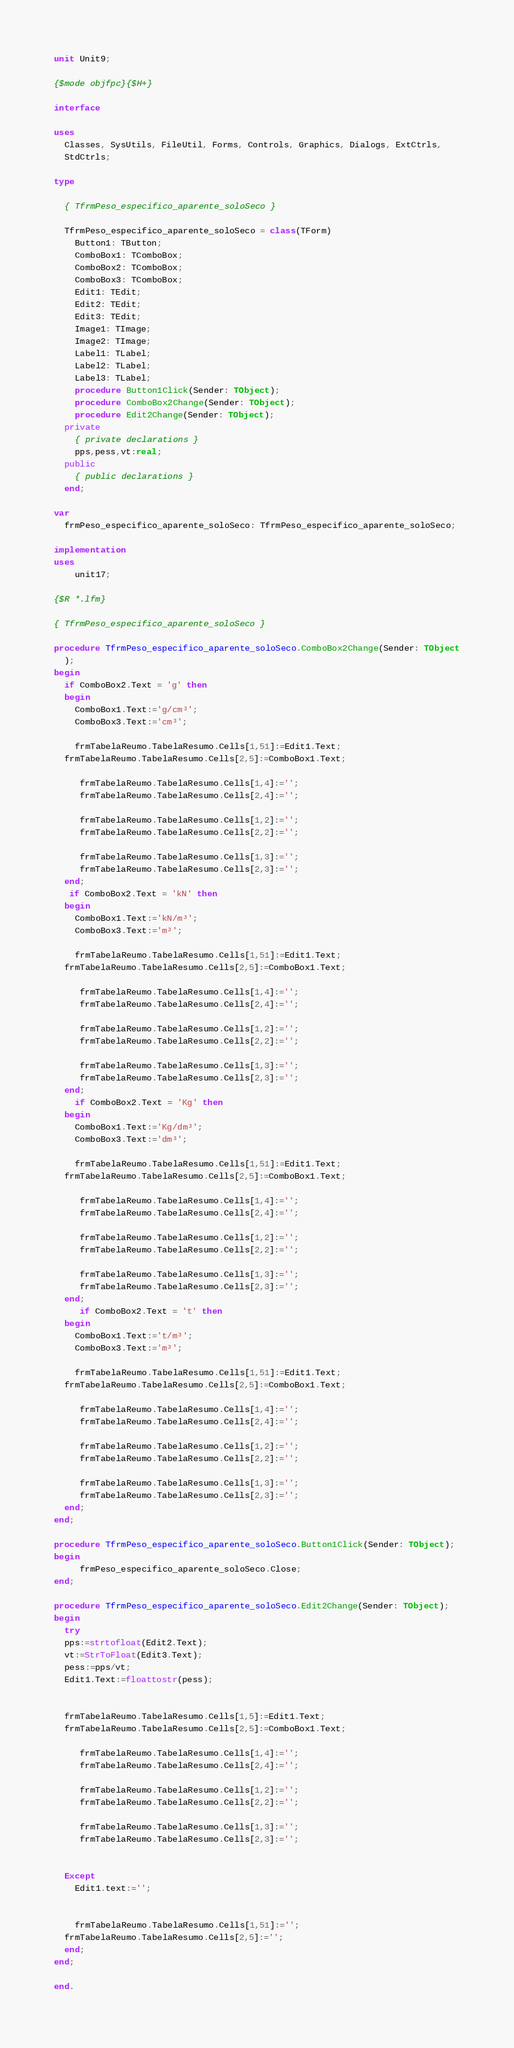<code> <loc_0><loc_0><loc_500><loc_500><_Pascal_>unit Unit9;

{$mode objfpc}{$H+}

interface

uses
  Classes, SysUtils, FileUtil, Forms, Controls, Graphics, Dialogs, ExtCtrls,
  StdCtrls;

type

  { TfrmPeso_especifico_aparente_soloSeco }

  TfrmPeso_especifico_aparente_soloSeco = class(TForm)
    Button1: TButton;
    ComboBox1: TComboBox;
    ComboBox2: TComboBox;
    ComboBox3: TComboBox;
    Edit1: TEdit;
    Edit2: TEdit;
    Edit3: TEdit;
    Image1: TImage;
    Image2: TImage;
    Label1: TLabel;
    Label2: TLabel;
    Label3: TLabel;
    procedure Button1Click(Sender: TObject);
    procedure ComboBox2Change(Sender: TObject);
    procedure Edit2Change(Sender: TObject);
  private
    { private declarations }
    pps,pess,vt:real;
  public
    { public declarations }
  end;

var
  frmPeso_especifico_aparente_soloSeco: TfrmPeso_especifico_aparente_soloSeco;

implementation
uses
    unit17;

{$R *.lfm}

{ TfrmPeso_especifico_aparente_soloSeco }

procedure TfrmPeso_especifico_aparente_soloSeco.ComboBox2Change(Sender: TObject
  );
begin
  if ComboBox2.Text = 'g' then
  begin
    ComboBox1.Text:='g/cm³';
    ComboBox3.Text:='cm³';

    frmTabelaReumo.TabelaResumo.Cells[1,51]:=Edit1.Text;
  frmTabelaReumo.TabelaResumo.Cells[2,5]:=ComboBox1.Text;

     frmTabelaReumo.TabelaResumo.Cells[1,4]:='';
     frmTabelaReumo.TabelaResumo.Cells[2,4]:='';

     frmTabelaReumo.TabelaResumo.Cells[1,2]:='';
     frmTabelaReumo.TabelaResumo.Cells[2,2]:='';

     frmTabelaReumo.TabelaResumo.Cells[1,3]:='';
     frmTabelaReumo.TabelaResumo.Cells[2,3]:='';
  end;
   if ComboBox2.Text = 'kN' then
  begin
    ComboBox1.Text:='kN/m³';
    ComboBox3.Text:='m³';

    frmTabelaReumo.TabelaResumo.Cells[1,51]:=Edit1.Text;
  frmTabelaReumo.TabelaResumo.Cells[2,5]:=ComboBox1.Text;

     frmTabelaReumo.TabelaResumo.Cells[1,4]:='';
     frmTabelaReumo.TabelaResumo.Cells[2,4]:='';

     frmTabelaReumo.TabelaResumo.Cells[1,2]:='';
     frmTabelaReumo.TabelaResumo.Cells[2,2]:='';

     frmTabelaReumo.TabelaResumo.Cells[1,3]:='';
     frmTabelaReumo.TabelaResumo.Cells[2,3]:='';
  end;
    if ComboBox2.Text = 'Kg' then
  begin
    ComboBox1.Text:='Kg/dm³';
    ComboBox3.Text:='dm³';

    frmTabelaReumo.TabelaResumo.Cells[1,51]:=Edit1.Text;
  frmTabelaReumo.TabelaResumo.Cells[2,5]:=ComboBox1.Text;

     frmTabelaReumo.TabelaResumo.Cells[1,4]:='';
     frmTabelaReumo.TabelaResumo.Cells[2,4]:='';

     frmTabelaReumo.TabelaResumo.Cells[1,2]:='';
     frmTabelaReumo.TabelaResumo.Cells[2,2]:='';

     frmTabelaReumo.TabelaResumo.Cells[1,3]:='';
     frmTabelaReumo.TabelaResumo.Cells[2,3]:='';
  end;
     if ComboBox2.Text = 't' then
  begin
    ComboBox1.Text:='t/m³';
    ComboBox3.Text:='m³';

    frmTabelaReumo.TabelaResumo.Cells[1,51]:=Edit1.Text;
  frmTabelaReumo.TabelaResumo.Cells[2,5]:=ComboBox1.Text;

     frmTabelaReumo.TabelaResumo.Cells[1,4]:='';
     frmTabelaReumo.TabelaResumo.Cells[2,4]:='';

     frmTabelaReumo.TabelaResumo.Cells[1,2]:='';
     frmTabelaReumo.TabelaResumo.Cells[2,2]:='';

     frmTabelaReumo.TabelaResumo.Cells[1,3]:='';
     frmTabelaReumo.TabelaResumo.Cells[2,3]:='';
  end;
end;

procedure TfrmPeso_especifico_aparente_soloSeco.Button1Click(Sender: TObject);
begin
     frmPeso_especifico_aparente_soloSeco.Close;
end;

procedure TfrmPeso_especifico_aparente_soloSeco.Edit2Change(Sender: TObject);
begin
  try
  pps:=strtofloat(Edit2.Text);
  vt:=StrToFloat(Edit3.Text);
  pess:=pps/vt;
  Edit1.Text:=floattostr(pess);


  frmTabelaReumo.TabelaResumo.Cells[1,5]:=Edit1.Text;
  frmTabelaReumo.TabelaResumo.Cells[2,5]:=ComboBox1.Text;

     frmTabelaReumo.TabelaResumo.Cells[1,4]:='';
     frmTabelaReumo.TabelaResumo.Cells[2,4]:='';

     frmTabelaReumo.TabelaResumo.Cells[1,2]:='';
     frmTabelaReumo.TabelaResumo.Cells[2,2]:='';

     frmTabelaReumo.TabelaResumo.Cells[1,3]:='';
     frmTabelaReumo.TabelaResumo.Cells[2,3]:='';


  Except
    Edit1.text:='';


    frmTabelaReumo.TabelaResumo.Cells[1,51]:='';
  frmTabelaReumo.TabelaResumo.Cells[2,5]:='';
  end;
end;

end.

</code> 